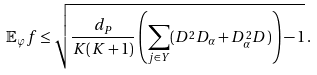<formula> <loc_0><loc_0><loc_500><loc_500>\mathbb { E } _ { \varphi } f \leq \sqrt { \frac { d _ { P } } { K ( K + 1 ) } \left ( \sum _ { j \in Y } ( D ^ { 2 } D _ { \alpha } + D _ { \alpha } ^ { 2 } D ) \right ) - 1 } \, .</formula> 